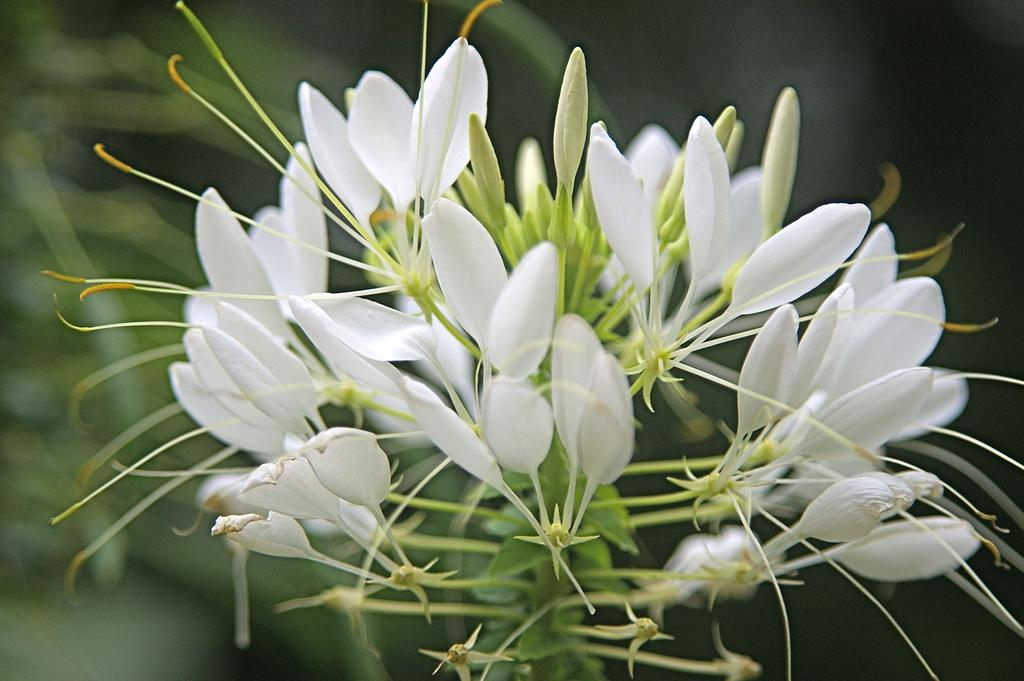What color are the flowers on the plant in the image? The flowers on the plant in the image are white-colored. What stage of growth are the flowers on the plant in the image? There are buds on the plant in the image, indicating that they are in the early stages of growth. Can you describe the background of the image? The background of the image is blurred. What type of tray is used to hold the belief in the image? There is no tray or belief present in the image; it features a plant with white-colored flowers and buds. 